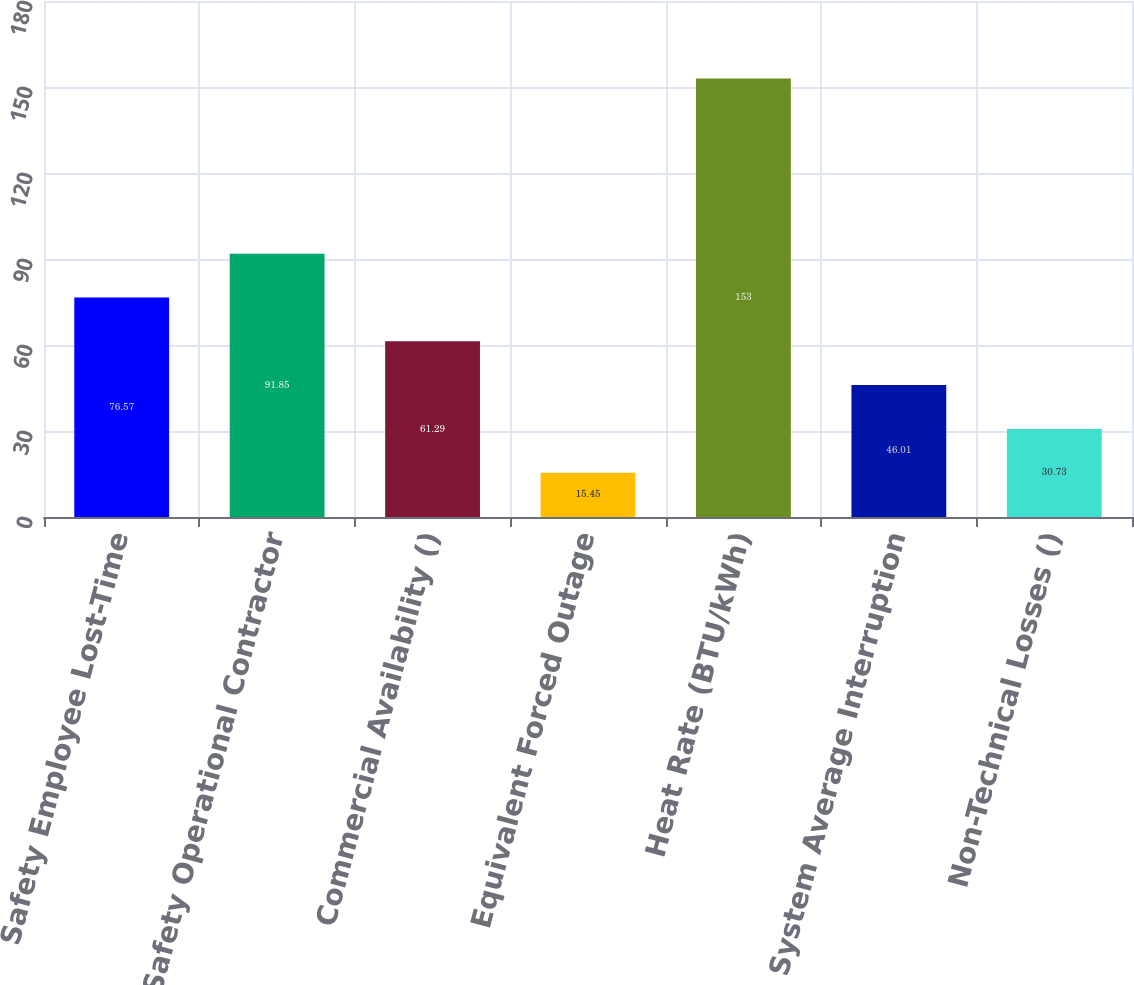<chart> <loc_0><loc_0><loc_500><loc_500><bar_chart><fcel>Safety Employee Lost-Time<fcel>Safety Operational Contractor<fcel>Commercial Availability ()<fcel>Equivalent Forced Outage<fcel>Heat Rate (BTU/kWh)<fcel>System Average Interruption<fcel>Non-Technical Losses ()<nl><fcel>76.57<fcel>91.85<fcel>61.29<fcel>15.45<fcel>153<fcel>46.01<fcel>30.73<nl></chart> 